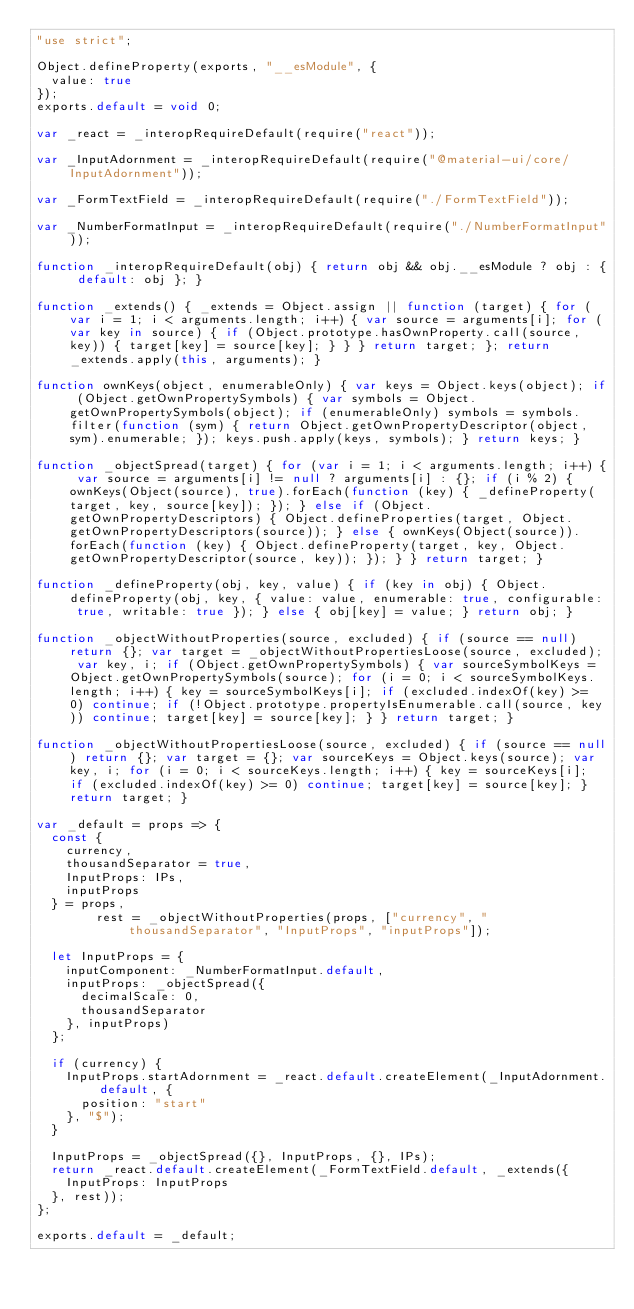Convert code to text. <code><loc_0><loc_0><loc_500><loc_500><_JavaScript_>"use strict";

Object.defineProperty(exports, "__esModule", {
  value: true
});
exports.default = void 0;

var _react = _interopRequireDefault(require("react"));

var _InputAdornment = _interopRequireDefault(require("@material-ui/core/InputAdornment"));

var _FormTextField = _interopRequireDefault(require("./FormTextField"));

var _NumberFormatInput = _interopRequireDefault(require("./NumberFormatInput"));

function _interopRequireDefault(obj) { return obj && obj.__esModule ? obj : { default: obj }; }

function _extends() { _extends = Object.assign || function (target) { for (var i = 1; i < arguments.length; i++) { var source = arguments[i]; for (var key in source) { if (Object.prototype.hasOwnProperty.call(source, key)) { target[key] = source[key]; } } } return target; }; return _extends.apply(this, arguments); }

function ownKeys(object, enumerableOnly) { var keys = Object.keys(object); if (Object.getOwnPropertySymbols) { var symbols = Object.getOwnPropertySymbols(object); if (enumerableOnly) symbols = symbols.filter(function (sym) { return Object.getOwnPropertyDescriptor(object, sym).enumerable; }); keys.push.apply(keys, symbols); } return keys; }

function _objectSpread(target) { for (var i = 1; i < arguments.length; i++) { var source = arguments[i] != null ? arguments[i] : {}; if (i % 2) { ownKeys(Object(source), true).forEach(function (key) { _defineProperty(target, key, source[key]); }); } else if (Object.getOwnPropertyDescriptors) { Object.defineProperties(target, Object.getOwnPropertyDescriptors(source)); } else { ownKeys(Object(source)).forEach(function (key) { Object.defineProperty(target, key, Object.getOwnPropertyDescriptor(source, key)); }); } } return target; }

function _defineProperty(obj, key, value) { if (key in obj) { Object.defineProperty(obj, key, { value: value, enumerable: true, configurable: true, writable: true }); } else { obj[key] = value; } return obj; }

function _objectWithoutProperties(source, excluded) { if (source == null) return {}; var target = _objectWithoutPropertiesLoose(source, excluded); var key, i; if (Object.getOwnPropertySymbols) { var sourceSymbolKeys = Object.getOwnPropertySymbols(source); for (i = 0; i < sourceSymbolKeys.length; i++) { key = sourceSymbolKeys[i]; if (excluded.indexOf(key) >= 0) continue; if (!Object.prototype.propertyIsEnumerable.call(source, key)) continue; target[key] = source[key]; } } return target; }

function _objectWithoutPropertiesLoose(source, excluded) { if (source == null) return {}; var target = {}; var sourceKeys = Object.keys(source); var key, i; for (i = 0; i < sourceKeys.length; i++) { key = sourceKeys[i]; if (excluded.indexOf(key) >= 0) continue; target[key] = source[key]; } return target; }

var _default = props => {
  const {
    currency,
    thousandSeparator = true,
    InputProps: IPs,
    inputProps
  } = props,
        rest = _objectWithoutProperties(props, ["currency", "thousandSeparator", "InputProps", "inputProps"]);

  let InputProps = {
    inputComponent: _NumberFormatInput.default,
    inputProps: _objectSpread({
      decimalScale: 0,
      thousandSeparator
    }, inputProps)
  };

  if (currency) {
    InputProps.startAdornment = _react.default.createElement(_InputAdornment.default, {
      position: "start"
    }, "$");
  }

  InputProps = _objectSpread({}, InputProps, {}, IPs);
  return _react.default.createElement(_FormTextField.default, _extends({
    InputProps: InputProps
  }, rest));
};

exports.default = _default;</code> 